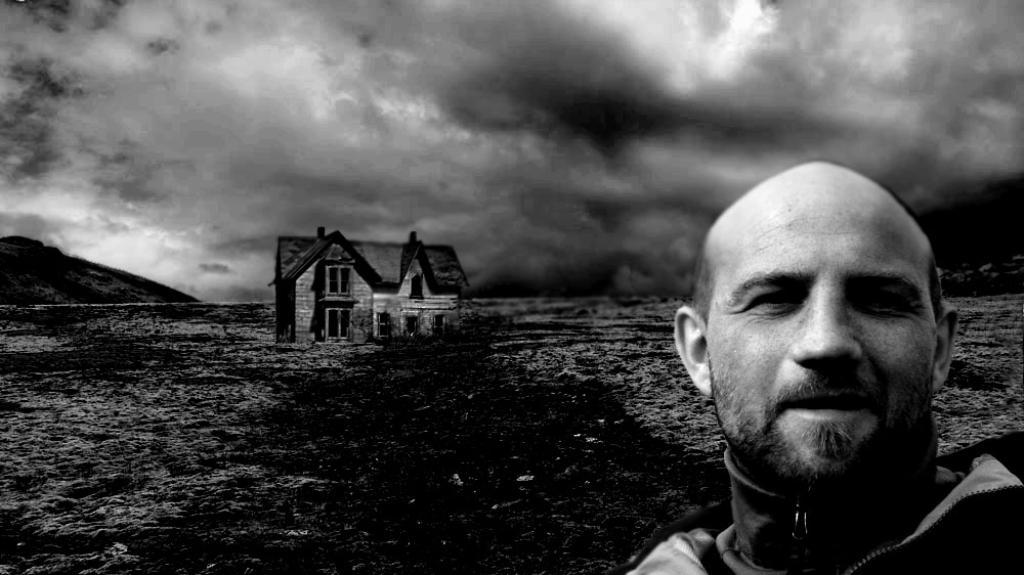What type of image is present in the picture? There is a graphical image in the picture. Can you describe any people in the picture? There is a man in the picture. What type of structure is visible in the picture? There is a house in the picture. What natural element can be seen in the picture? There is water visible in the picture. What geographical feature is present in the picture? There is a hill in the picture. How would you describe the weather in the picture? The sky is cloudy in the picture. How many women are using quills to write in the picture? There are no women or quills present in the image. What type of grass is growing on the hill in the picture? There is no grass visible in the picture; only a hill is present. 